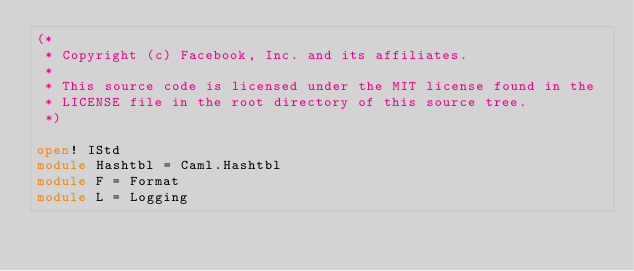<code> <loc_0><loc_0><loc_500><loc_500><_OCaml_>(*
 * Copyright (c) Facebook, Inc. and its affiliates.
 *
 * This source code is licensed under the MIT license found in the
 * LICENSE file in the root directory of this source tree.
 *)

open! IStd
module Hashtbl = Caml.Hashtbl
module F = Format
module L = Logging
</code> 